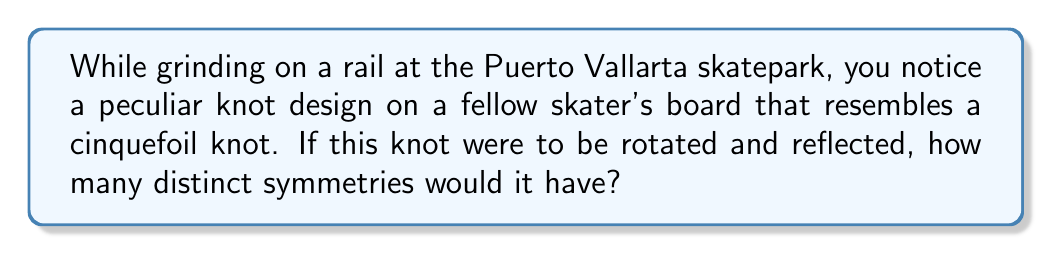Can you solve this math problem? Let's approach this step-by-step:

1) A cinquefoil knot, also known as a $(5,2)$-torus knot, has a 5-fold rotational symmetry and a reflection symmetry.

2) The rotational symmetry means that the knot looks the same after rotations of $\frac{2\pi}{5}$, $\frac{4\pi}{5}$, $\frac{6\pi}{5}$, $\frac{8\pi}{5}$, and $2\pi$ (which is equivalent to no rotation).

3) The reflection symmetry means that the knot looks the same when reflected across any of its 5 axes of symmetry.

4) To count the total number of symmetries, we need to consider:
   a) The identity symmetry (no change)
   b) The 4 non-trivial rotations
   c) The 5 reflections

5) Therefore, the total number of symmetries is:

   $$1 + 4 + 5 = 10$$

6) In group theory terms, this symmetry group is known as the dihedral group $D_5$, which has order 10.
Answer: 10 